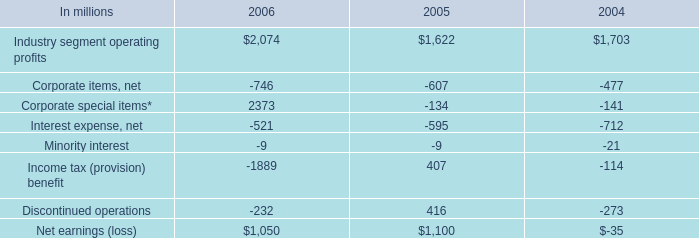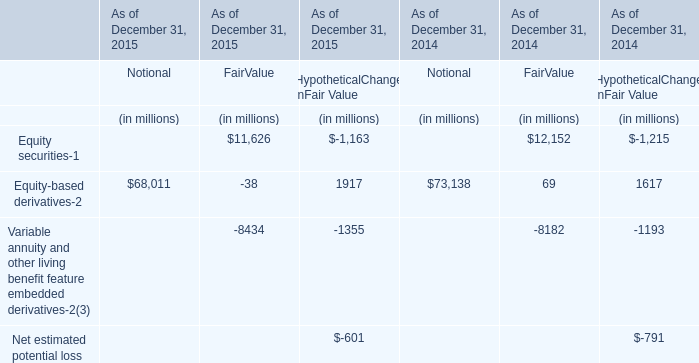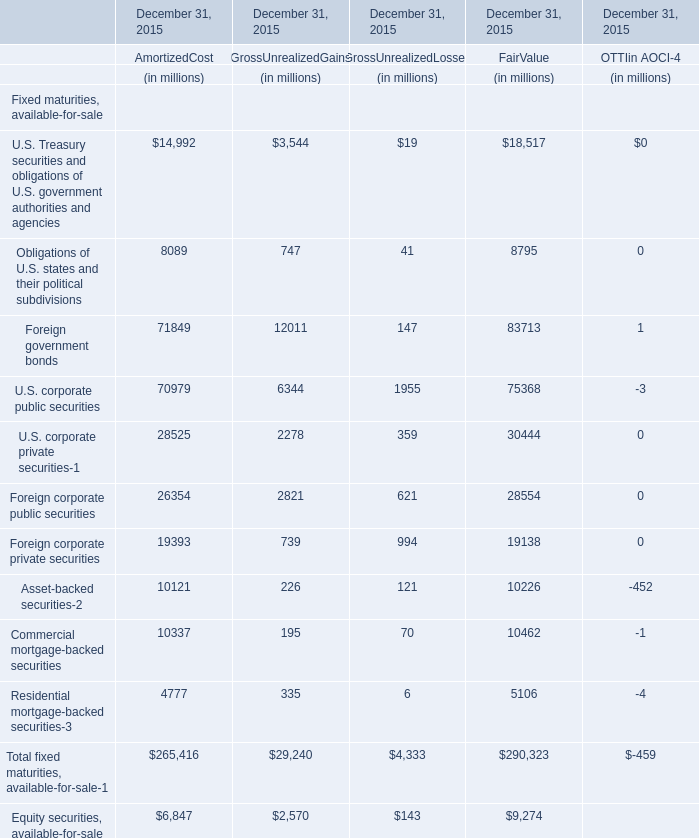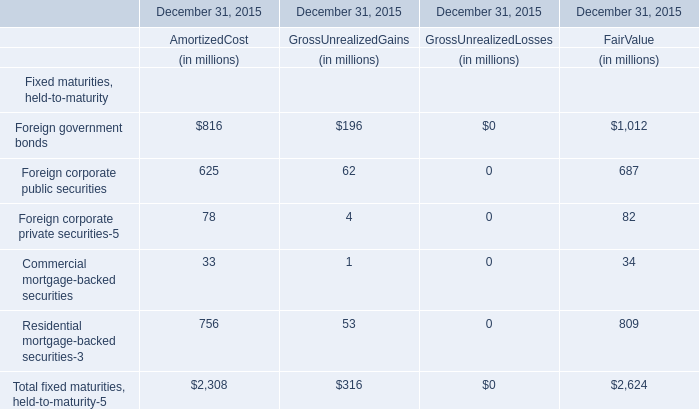what was the percentage change in industry segment operating profits from 2005 to 2006? 
Computations: ((2074 - 1622) / 1622)
Answer: 0.27867. 